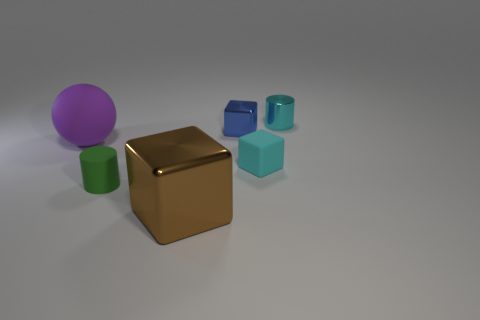The small thing that is both in front of the ball and on the right side of the large brown block has what shape?
Your answer should be very brief. Cube. Is there a cyan metal thing that has the same shape as the small green matte thing?
Provide a succinct answer. Yes. Is the size of the rubber object that is behind the small rubber block the same as the shiny object that is in front of the tiny blue metallic thing?
Provide a succinct answer. Yes. Are there more tiny rubber things than small things?
Provide a short and direct response. No. What number of purple spheres have the same material as the large block?
Offer a terse response. 0. Is the shape of the big brown metallic thing the same as the blue metallic thing?
Offer a very short reply. Yes. There is a cyan object behind the big object behind the small cyan thing left of the cyan metallic thing; how big is it?
Your answer should be very brief. Small. There is a sphere on the left side of the large brown object; is there a tiny cylinder that is in front of it?
Provide a succinct answer. Yes. There is a cylinder that is left of the large brown object in front of the large purple ball; how many large blocks are in front of it?
Ensure brevity in your answer.  1. What color is the shiny object that is behind the large brown block and to the left of the small cyan rubber block?
Give a very brief answer. Blue. 